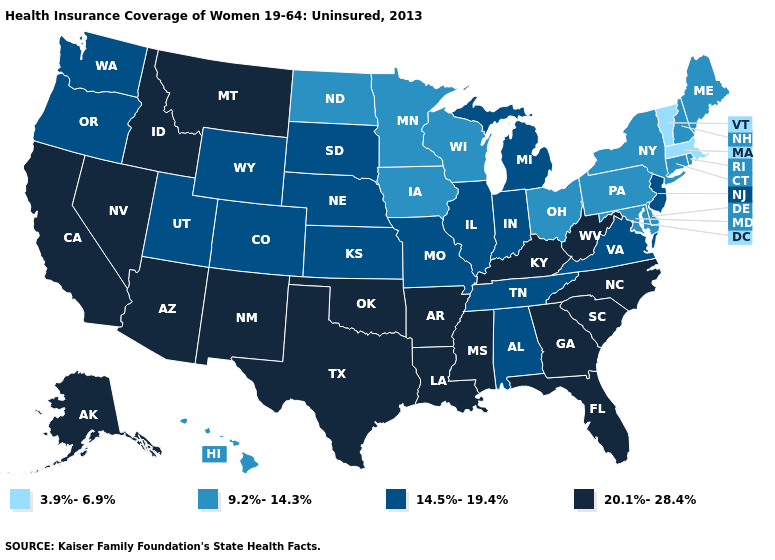What is the highest value in states that border Nebraska?
Concise answer only. 14.5%-19.4%. What is the value of New York?
Answer briefly. 9.2%-14.3%. Which states have the lowest value in the USA?
Write a very short answer. Massachusetts, Vermont. Does North Carolina have the same value as Louisiana?
Keep it brief. Yes. Name the states that have a value in the range 3.9%-6.9%?
Answer briefly. Massachusetts, Vermont. Among the states that border Iowa , does South Dakota have the lowest value?
Write a very short answer. No. Among the states that border Pennsylvania , does Delaware have the highest value?
Quick response, please. No. Name the states that have a value in the range 3.9%-6.9%?
Quick response, please. Massachusetts, Vermont. What is the highest value in states that border Minnesota?
Answer briefly. 14.5%-19.4%. What is the value of Virginia?
Answer briefly. 14.5%-19.4%. How many symbols are there in the legend?
Write a very short answer. 4. Does Nebraska have the lowest value in the USA?
Short answer required. No. Name the states that have a value in the range 20.1%-28.4%?
Give a very brief answer. Alaska, Arizona, Arkansas, California, Florida, Georgia, Idaho, Kentucky, Louisiana, Mississippi, Montana, Nevada, New Mexico, North Carolina, Oklahoma, South Carolina, Texas, West Virginia. Which states have the lowest value in the USA?
Keep it brief. Massachusetts, Vermont. Name the states that have a value in the range 3.9%-6.9%?
Short answer required. Massachusetts, Vermont. 